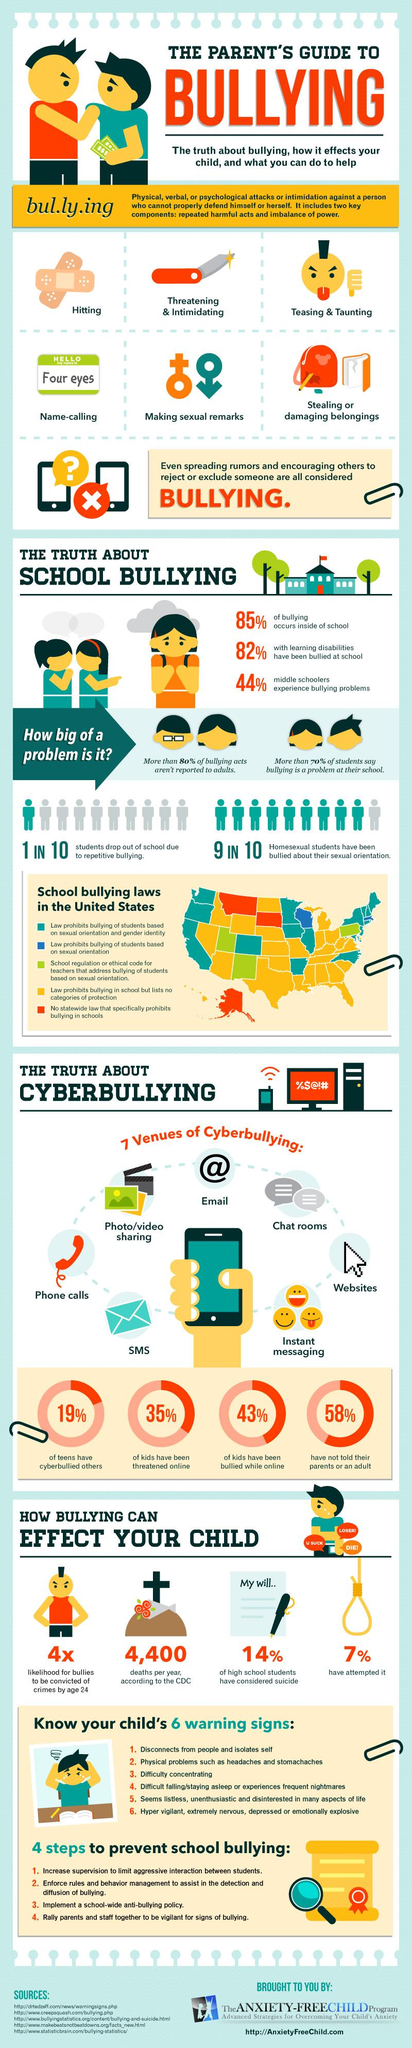Indicate a few pertinent items in this graphic. It is estimated that by the age of 24, bullies in the United States have a high likelihood of being convicted of crimes. This is four times the likelihood of their peers who did not engage in bullying behavior. According to a recent survey, 43% of American children have been bullied while using the internet. According to a study, approximately 7% of children in the United States have attempted suicide as a result of bullying. According to the Centers for Disease Control and Prevention, an estimated 4,400 children in the United States die every year as a result of bullying. Data shows that 19% of teenagers in the United States have cyberbullied others, a concerning statistic that highlights the need for increased awareness and action to address this issue. 